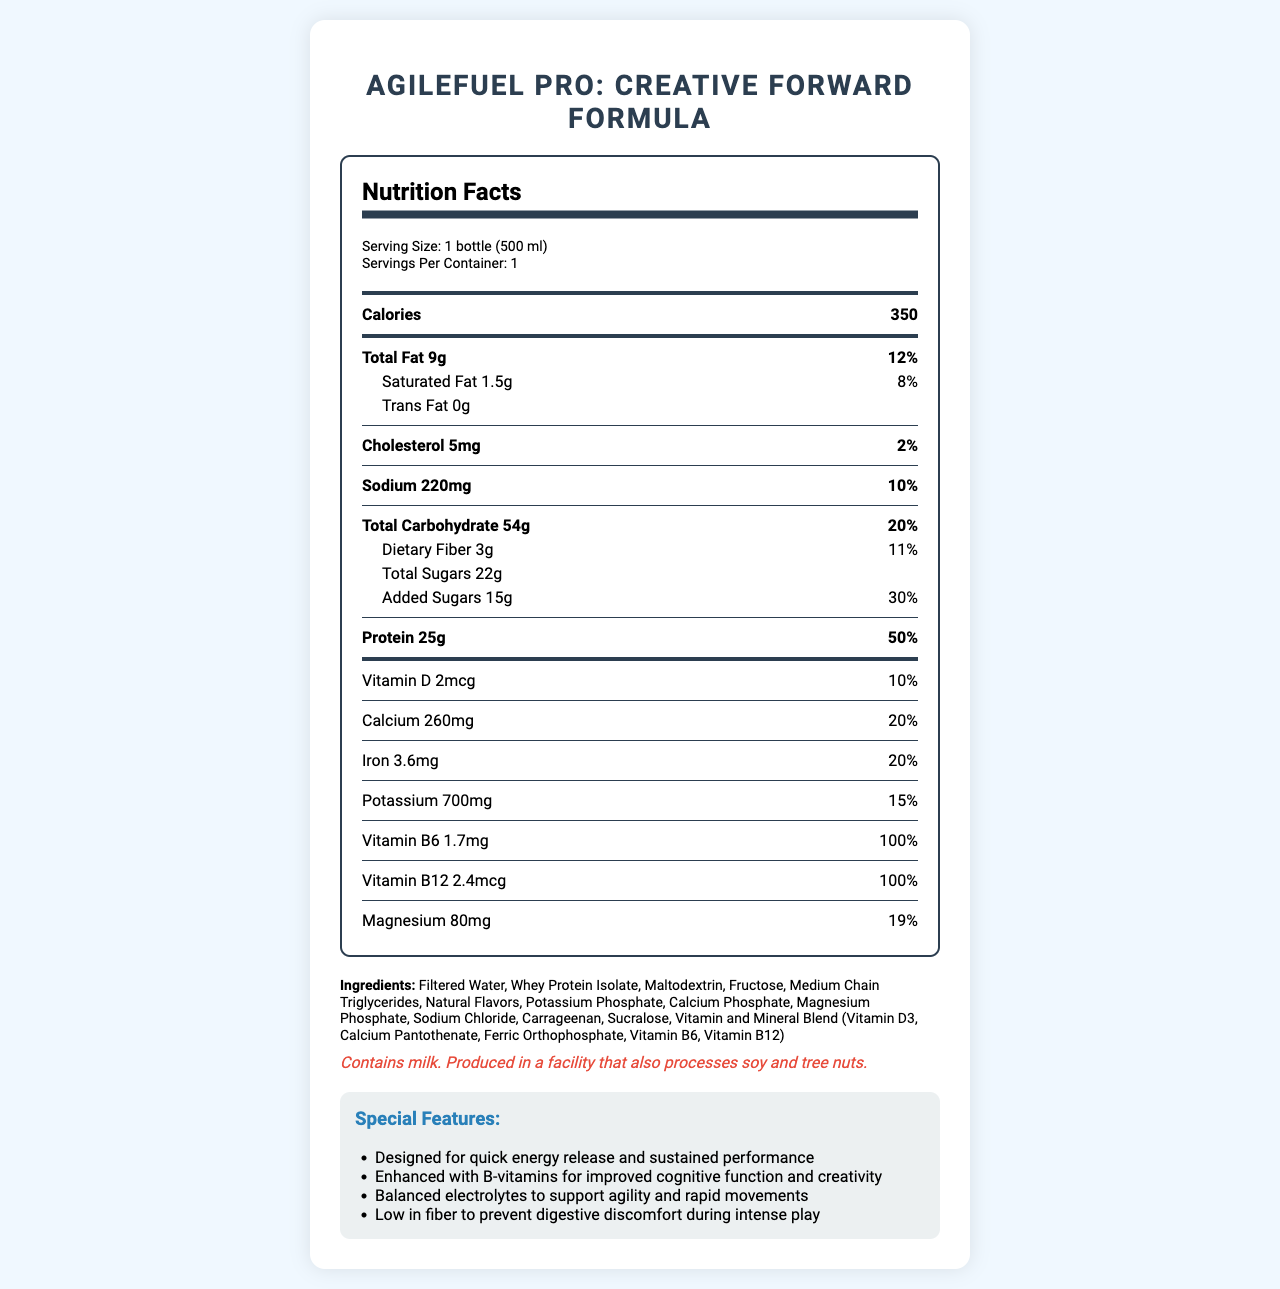what is the serving size for AgileFuel Pro: Creative Forward Formula? The serving size is specified in the Nutrition Facts section of the document as "1 bottle (500 ml)."
Answer: 1 bottle (500 ml) how many grams of protein are in one serving? The amount of protein per serving is listed under the protein section as "25g."
Answer: 25g What is the daily value percentage for Vitamin B6? The daily value percentage for Vitamin B6 is stated as "100%" in the nutrition facts.
Answer: 100% What are the ingredients in AgileFuel Pro: Creative Forward Formula? The ingredients are listed at the bottom of the document under the "Ingredients" section.
Answer: Filtered Water, Whey Protein Isolate, Maltodextrin, Fructose, Medium Chain Triglycerides, Natural Flavors, Potassium Phosphate, Calcium Phosphate, Magnesium Phosphate, Sodium Chloride, Carrageenan, Sucralose, Vitamin and Mineral Blend (Vitamin D3, Calcium Pantothenate, Ferric Orthophosphate, Vitamin B6, Vitamin B12) Are there any allergens in this product? If so, what are they? The allergen information is provided in the document: "Contains milk. Produced in a facility that also processes soy and tree nuts."
Answer: Contains milk. Produced in a facility that also processes soy and tree nuts. How many calories are in a single serving of this shake? The document lists the number of calories per serving as 350, which is indicated under the calories section.
Answer: 350 Which of the following is a feature of AgileFuel Pro: Creative Forward Formula? 
1. High in Fiber 
2. Designed for quick energy release 
3. Low in Protein 
4. No Added Sugars The special features section lists, "Designed for quick energy release and sustained performance" as one of the features.
Answer: 2 Which vitamin is present at 100% daily value in one serving? 
A. Vitamin D
B. Vitamin B6
C. Vitamin B12
D. Vitamin C The document shows that Vitamin B12 is present at 100% of the daily value in one serving.
Answer: C Is the AgileFuel Pro: Creative Forward Formula high in protein? The product contains 25g of protein per serving, which is 50% of the daily value, indicating it is high in protein.
Answer: Yes Summarize the nutritional profile and special features of the AgileFuel Pro: Creative Forward Formula. The document provides a detailed nutrition facts label along with information on ingredients and special features. The shake is designed to support intense physical and mental activities involved in sports.
Answer: The AgileFuel Pro: Creative Forward Formula is a pre-game meal replacement shake designed for creative forwards. A single serving is 500 ml and contains 350 calories. It includes 9g of total fat, 54g of total carbohydrates, and 25g of protein. The shake is enhanced with vitamins and minerals such as Vitamin B6, Vitamin B12, calcium, and magnesium. Special features include quick energy release, support for cognitive function, balanced electrolytes for agility, and low fiber to prevent digestive discomfort. What is the specific amount of Potassium in one serving? The document indicates that one serving contains 700mg of Potassium, which is shown under the minerals section.
Answer: 700mg How much saturated fat is in the shake? The amount of saturated fat per serving is listed as 1.5g in the document.
Answer: 1.5g What flavor options are available for AgileFuel Pro: Creative Forward Formula? The document does not provide any information on flavor options.
Answer: Not enough information What percentage of the daily value is provided by the dietary fiber in one serving? The document specifies that the dietary fiber content in one serving is 3g, which equals 11% of the daily value.
Answer: 11% Why might the shake be low in fiber? The document mentions that the product is low in fiber to prevent digestive discomfort during intense play. This is noted in the special features section.
Answer: To prevent digestive discomfort during intense play 